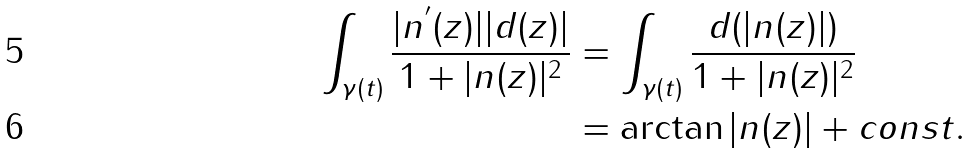Convert formula to latex. <formula><loc_0><loc_0><loc_500><loc_500>\int _ { \gamma ( t ) } \frac { | n ^ { ^ { \prime } } ( z ) | | d ( z ) | } { 1 + | n ( z ) | ^ { 2 } } & = \int _ { \gamma ( t ) } \frac { d ( | n ( z ) | ) } { 1 + | n ( z ) | ^ { 2 } } \\ & = \arctan | n ( z ) | + c o n s t .</formula> 